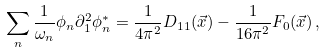<formula> <loc_0><loc_0><loc_500><loc_500>\sum _ { n } \frac { 1 } { \omega _ { n } } \phi _ { n } \partial _ { 1 } ^ { 2 } \phi _ { n } ^ { * } = \frac { 1 } { 4 \pi ^ { 2 } } D _ { 1 1 } ( \vec { x } ) - \frac { 1 } { 1 6 \pi ^ { 2 } } F _ { 0 } ( \vec { x } ) \, ,</formula> 